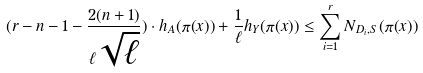Convert formula to latex. <formula><loc_0><loc_0><loc_500><loc_500>( r - n - 1 - \frac { 2 ( n + 1 ) } { \ell \sqrt { \ell } } ) \cdot h _ { A } ( \pi ( x ) ) + \frac { 1 } { \ell } h _ { Y } ( \pi ( x ) ) \leq \sum _ { i = 1 } ^ { r } N _ { D _ { i } , S } ( \pi ( x ) )</formula> 